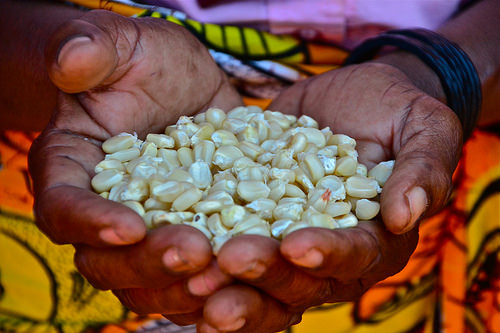<image>
Is the bracelet on the grain? No. The bracelet is not positioned on the grain. They may be near each other, but the bracelet is not supported by or resting on top of the grain. 